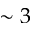<formula> <loc_0><loc_0><loc_500><loc_500>\sim 3</formula> 